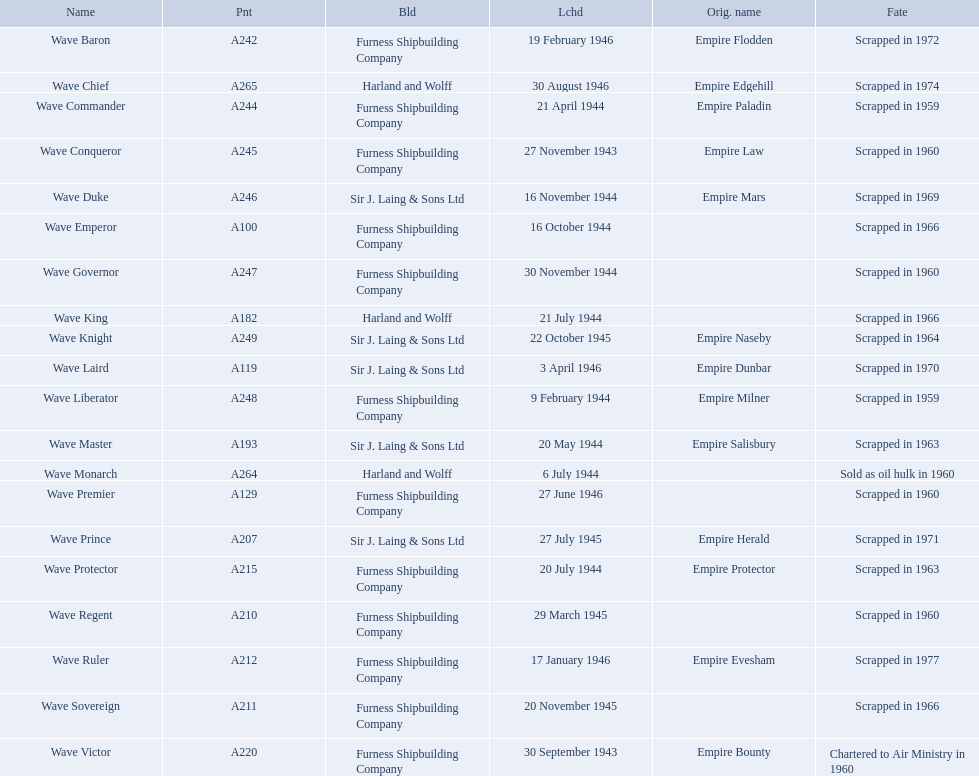What date was the wave victor launched? 30 September 1943. What other oiler was launched that same year? Wave Conqueror. What year was the wave victor launched? 30 September 1943. What other ship was launched in 1943? Wave Conqueror. 